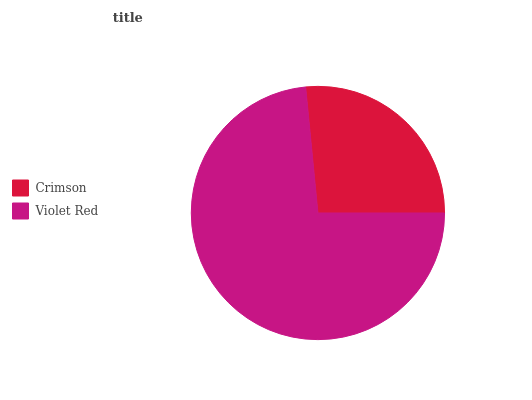Is Crimson the minimum?
Answer yes or no. Yes. Is Violet Red the maximum?
Answer yes or no. Yes. Is Violet Red the minimum?
Answer yes or no. No. Is Violet Red greater than Crimson?
Answer yes or no. Yes. Is Crimson less than Violet Red?
Answer yes or no. Yes. Is Crimson greater than Violet Red?
Answer yes or no. No. Is Violet Red less than Crimson?
Answer yes or no. No. Is Violet Red the high median?
Answer yes or no. Yes. Is Crimson the low median?
Answer yes or no. Yes. Is Crimson the high median?
Answer yes or no. No. Is Violet Red the low median?
Answer yes or no. No. 